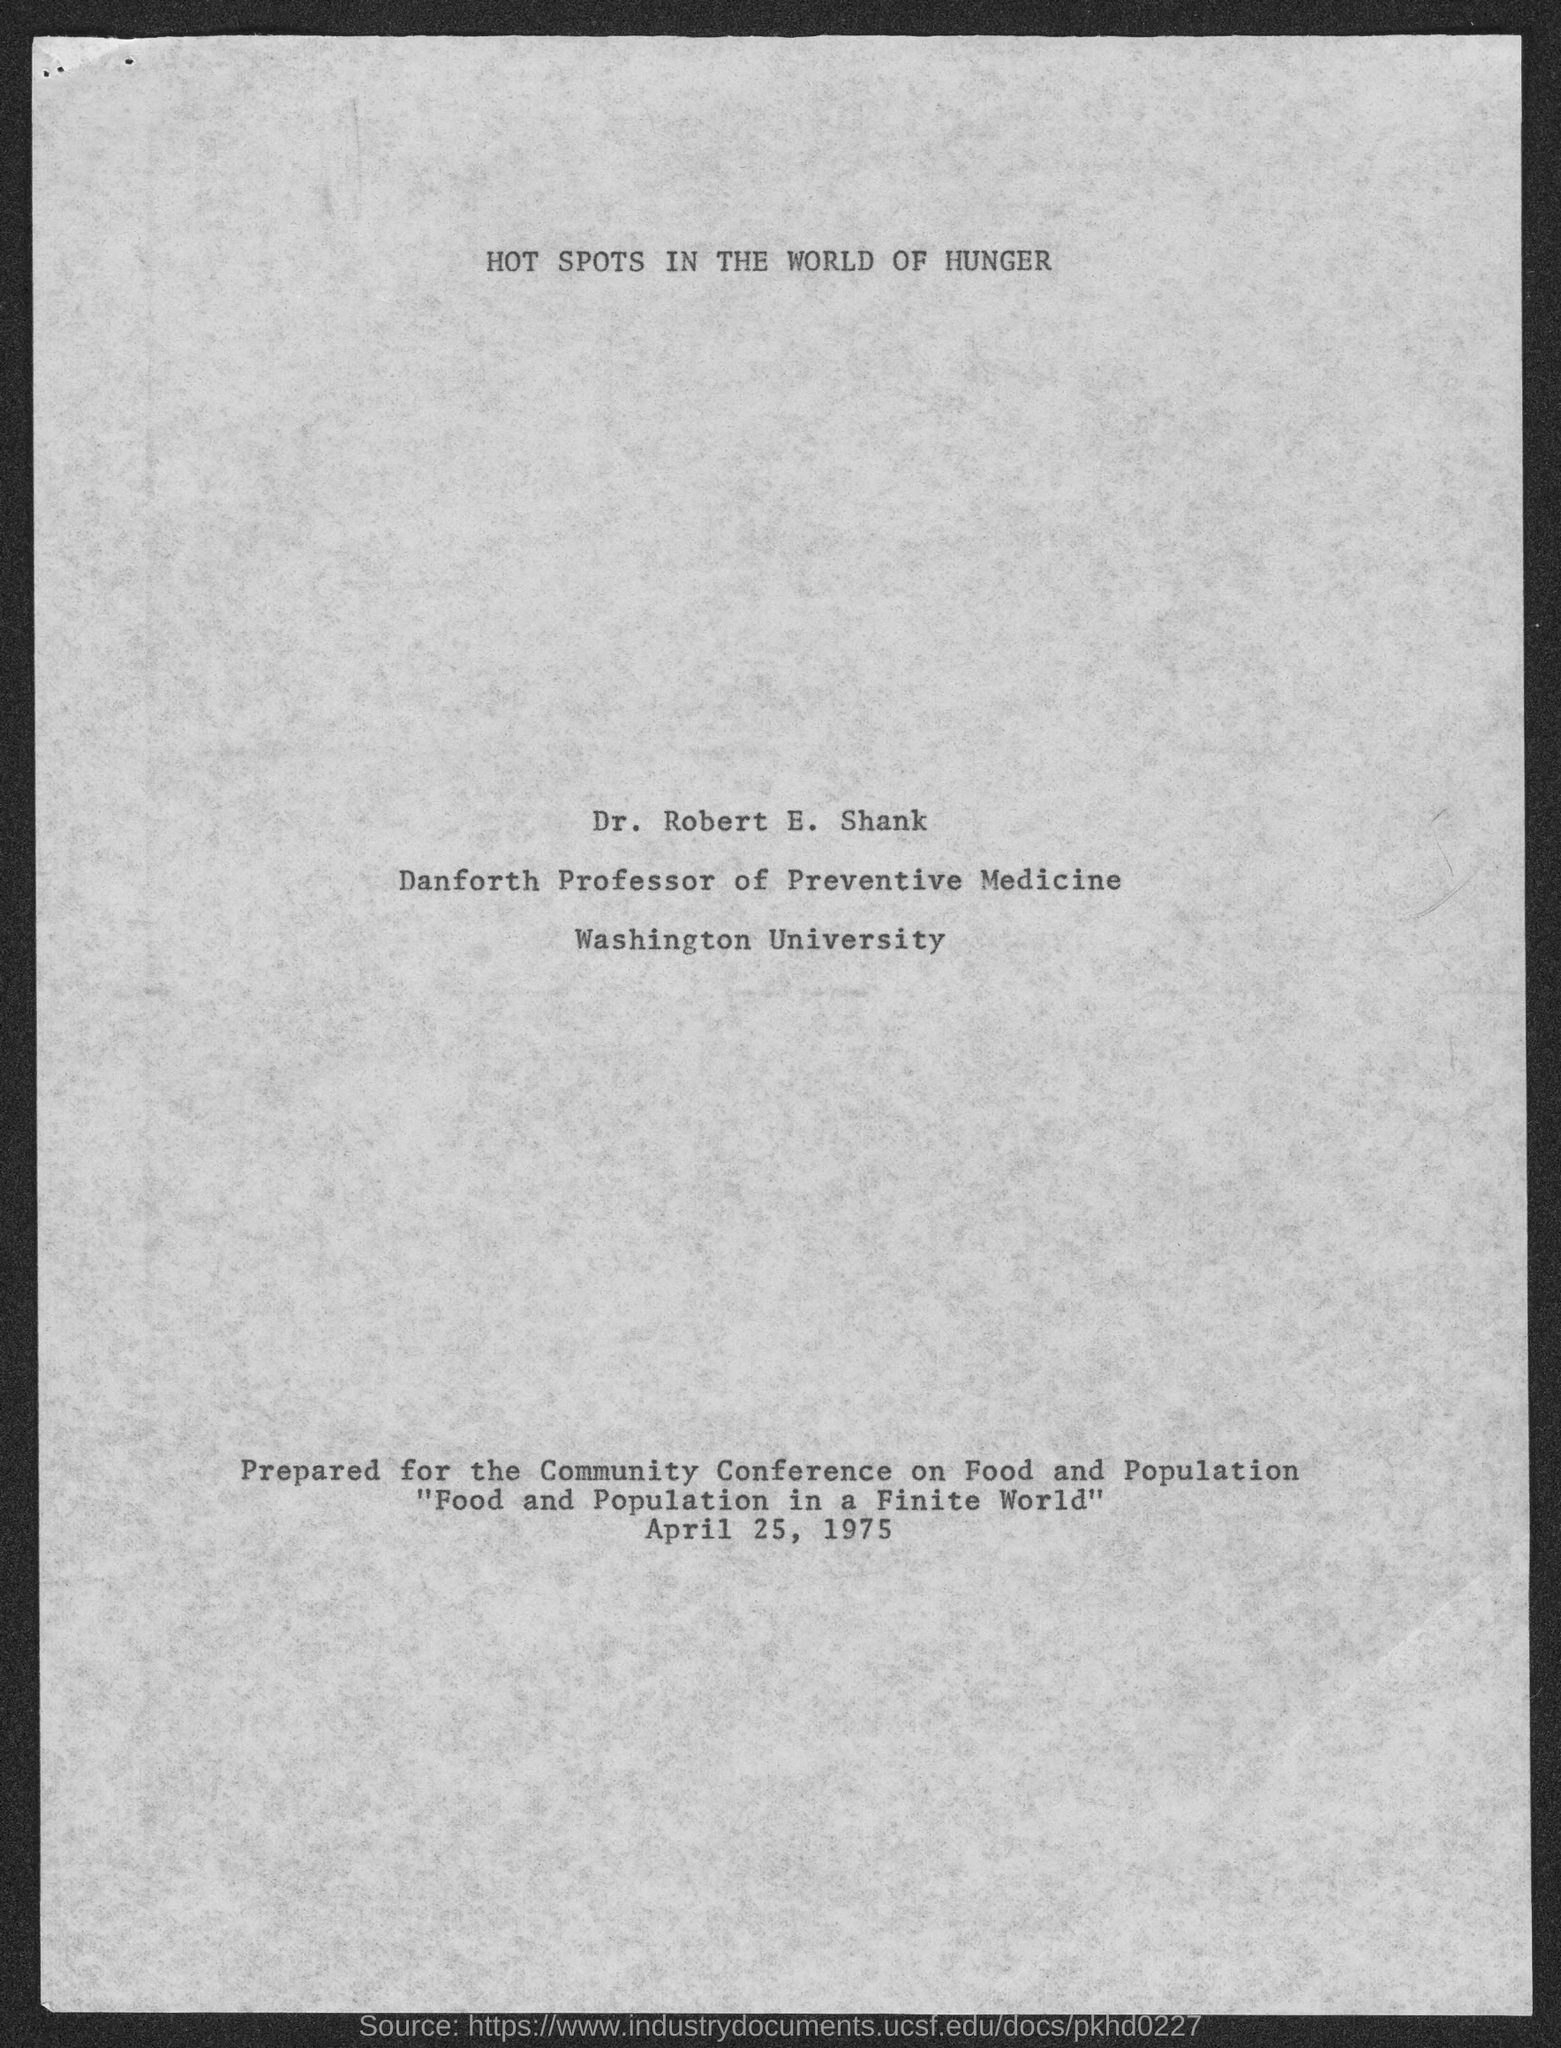Draw attention to some important aspects in this diagram. Dr. Robert E. Shank is affiliated with Washington University. Dr. Robert E. Shank is the Danforth Professor of Preventive Medicine. 